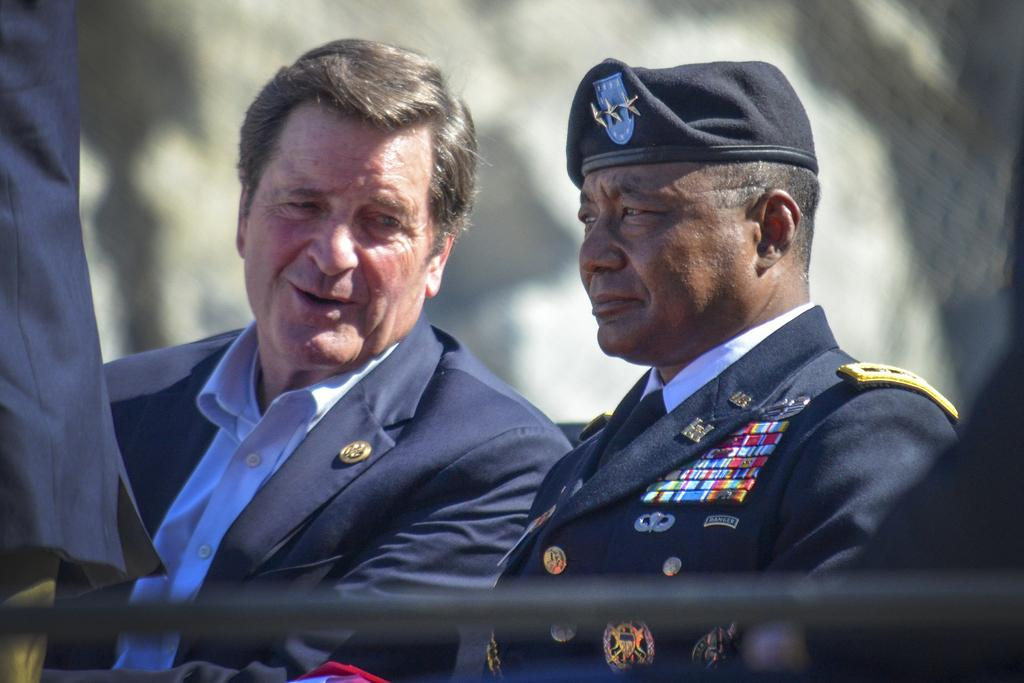How many persons with blazers are in the image? There are two persons with blazers in the image. What is the appearance of the person with a hat in the image? The person with a hat is in the image. Can you describe the background of the image? The background of the image is blurred. What type of honey is being used to whistle in the image? There is no honey or whistling present in the image. What force is being applied to the person with a hat in the image? There is no force being applied to the person with a hat in the image. 